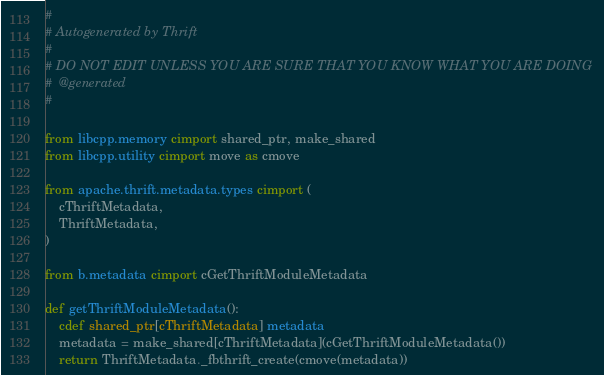<code> <loc_0><loc_0><loc_500><loc_500><_Cython_>#
# Autogenerated by Thrift
#
# DO NOT EDIT UNLESS YOU ARE SURE THAT YOU KNOW WHAT YOU ARE DOING
#  @generated
#

from libcpp.memory cimport shared_ptr, make_shared
from libcpp.utility cimport move as cmove

from apache.thrift.metadata.types cimport (
    cThriftMetadata,
    ThriftMetadata,
)

from b.metadata cimport cGetThriftModuleMetadata

def getThriftModuleMetadata():
    cdef shared_ptr[cThriftMetadata] metadata
    metadata = make_shared[cThriftMetadata](cGetThriftModuleMetadata())
    return ThriftMetadata._fbthrift_create(cmove(metadata))
</code> 